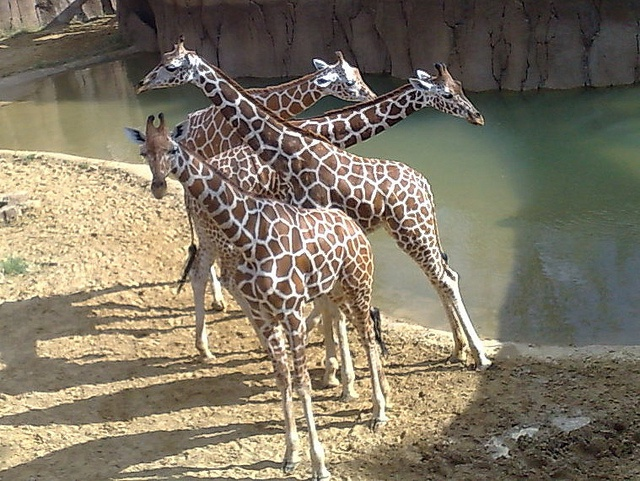Describe the objects in this image and their specific colors. I can see giraffe in gray, ivory, and darkgray tones, giraffe in gray, white, darkgray, and black tones, giraffe in gray, black, and darkgray tones, and giraffe in gray, darkgray, maroon, and white tones in this image. 